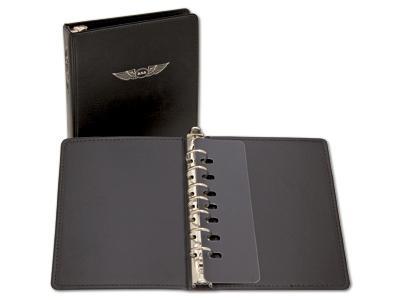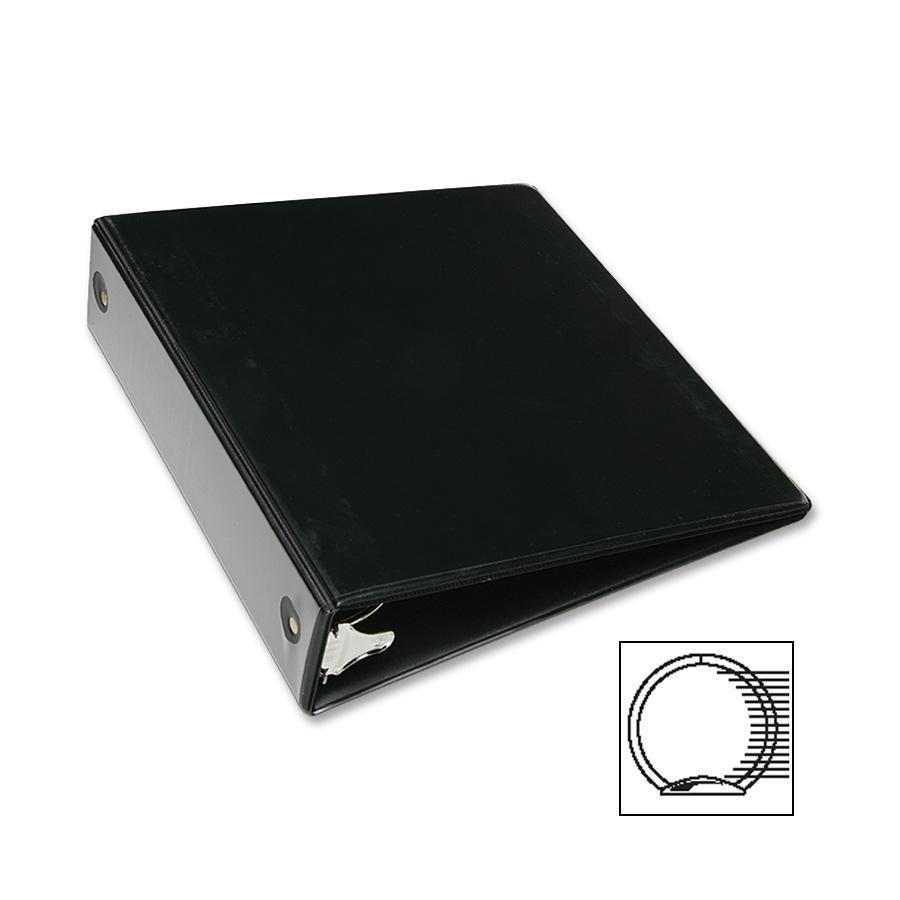The first image is the image on the left, the second image is the image on the right. For the images shown, is this caption "Two white notebooks, one open and one closed, are shown in one image, while only one notebook lying flat is in the second image." true? Answer yes or no. No. The first image is the image on the left, the second image is the image on the right. Examine the images to the left and right. Is the description "All images show only black binders." accurate? Answer yes or no. Yes. 